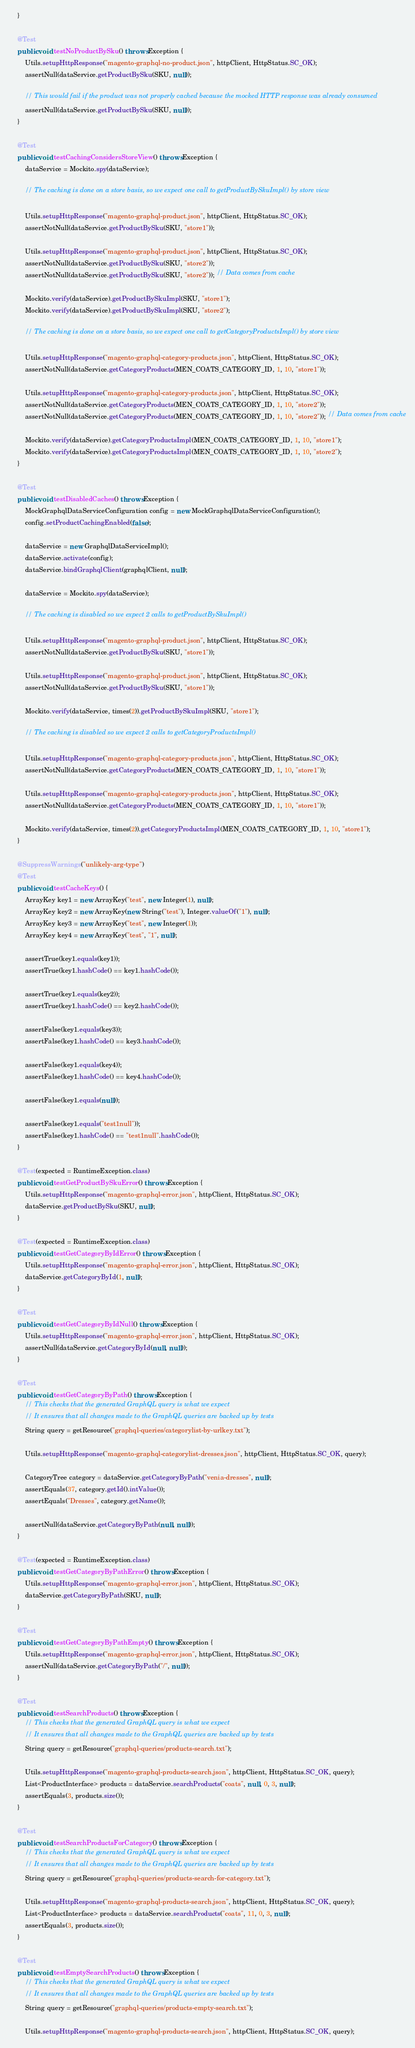<code> <loc_0><loc_0><loc_500><loc_500><_Java_>    }

    @Test
    public void testNoProductBySku() throws Exception {
        Utils.setupHttpResponse("magento-graphql-no-product.json", httpClient, HttpStatus.SC_OK);
        assertNull(dataService.getProductBySku(SKU, null));

        // This would fail if the product was not properly cached because the mocked HTTP response was already consumed
        assertNull(dataService.getProductBySku(SKU, null));
    }

    @Test
    public void testCachingConsidersStoreView() throws Exception {
        dataService = Mockito.spy(dataService);

        // The caching is done on a store basis, so we expect one call to getProductBySkuImpl() by store view

        Utils.setupHttpResponse("magento-graphql-product.json", httpClient, HttpStatus.SC_OK);
        assertNotNull(dataService.getProductBySku(SKU, "store1"));

        Utils.setupHttpResponse("magento-graphql-product.json", httpClient, HttpStatus.SC_OK);
        assertNotNull(dataService.getProductBySku(SKU, "store2"));
        assertNotNull(dataService.getProductBySku(SKU, "store2")); // Data comes from cache

        Mockito.verify(dataService).getProductBySkuImpl(SKU, "store1");
        Mockito.verify(dataService).getProductBySkuImpl(SKU, "store2");

        // The caching is done on a store basis, so we expect one call to getCategoryProductsImpl() by store view

        Utils.setupHttpResponse("magento-graphql-category-products.json", httpClient, HttpStatus.SC_OK);
        assertNotNull(dataService.getCategoryProducts(MEN_COATS_CATEGORY_ID, 1, 10, "store1"));

        Utils.setupHttpResponse("magento-graphql-category-products.json", httpClient, HttpStatus.SC_OK);
        assertNotNull(dataService.getCategoryProducts(MEN_COATS_CATEGORY_ID, 1, 10, "store2"));
        assertNotNull(dataService.getCategoryProducts(MEN_COATS_CATEGORY_ID, 1, 10, "store2")); // Data comes from cache

        Mockito.verify(dataService).getCategoryProductsImpl(MEN_COATS_CATEGORY_ID, 1, 10, "store1");
        Mockito.verify(dataService).getCategoryProductsImpl(MEN_COATS_CATEGORY_ID, 1, 10, "store2");
    }

    @Test
    public void testDisabledCaches() throws Exception {
        MockGraphqlDataServiceConfiguration config = new MockGraphqlDataServiceConfiguration();
        config.setProductCachingEnabled(false);

        dataService = new GraphqlDataServiceImpl();
        dataService.activate(config);
        dataService.bindGraphqlClient(graphqlClient, null);

        dataService = Mockito.spy(dataService);

        // The caching is disabled so we expect 2 calls to getProductBySkuImpl()

        Utils.setupHttpResponse("magento-graphql-product.json", httpClient, HttpStatus.SC_OK);
        assertNotNull(dataService.getProductBySku(SKU, "store1"));

        Utils.setupHttpResponse("magento-graphql-product.json", httpClient, HttpStatus.SC_OK);
        assertNotNull(dataService.getProductBySku(SKU, "store1"));

        Mockito.verify(dataService, times(2)).getProductBySkuImpl(SKU, "store1");

        // The caching is disabled so we expect 2 calls to getCategoryProductsImpl()

        Utils.setupHttpResponse("magento-graphql-category-products.json", httpClient, HttpStatus.SC_OK);
        assertNotNull(dataService.getCategoryProducts(MEN_COATS_CATEGORY_ID, 1, 10, "store1"));

        Utils.setupHttpResponse("magento-graphql-category-products.json", httpClient, HttpStatus.SC_OK);
        assertNotNull(dataService.getCategoryProducts(MEN_COATS_CATEGORY_ID, 1, 10, "store1"));

        Mockito.verify(dataService, times(2)).getCategoryProductsImpl(MEN_COATS_CATEGORY_ID, 1, 10, "store1");
    }

    @SuppressWarnings("unlikely-arg-type")
    @Test
    public void testCacheKeys() {
        ArrayKey key1 = new ArrayKey("test", new Integer(1), null);
        ArrayKey key2 = new ArrayKey(new String("test"), Integer.valueOf("1"), null);
        ArrayKey key3 = new ArrayKey("test", new Integer(1));
        ArrayKey key4 = new ArrayKey("test", "1", null);

        assertTrue(key1.equals(key1));
        assertTrue(key1.hashCode() == key1.hashCode());

        assertTrue(key1.equals(key2));
        assertTrue(key1.hashCode() == key2.hashCode());

        assertFalse(key1.equals(key3));
        assertFalse(key1.hashCode() == key3.hashCode());

        assertFalse(key1.equals(key4));
        assertFalse(key1.hashCode() == key4.hashCode());

        assertFalse(key1.equals(null));

        assertFalse(key1.equals("test1null"));
        assertFalse(key1.hashCode() == "test1null".hashCode());
    }

    @Test(expected = RuntimeException.class)
    public void testGetProductBySkuError() throws Exception {
        Utils.setupHttpResponse("magento-graphql-error.json", httpClient, HttpStatus.SC_OK);
        dataService.getProductBySku(SKU, null);
    }

    @Test(expected = RuntimeException.class)
    public void testGetCategoryByIdError() throws Exception {
        Utils.setupHttpResponse("magento-graphql-error.json", httpClient, HttpStatus.SC_OK);
        dataService.getCategoryById(1, null);
    }

    @Test
    public void testGetCategoryByIdNull() throws Exception {
        Utils.setupHttpResponse("magento-graphql-error.json", httpClient, HttpStatus.SC_OK);
        assertNull(dataService.getCategoryById(null, null));
    }

    @Test
    public void testGetCategoryByPath() throws Exception {
        // This checks that the generated GraphQL query is what we expect
        // It ensures that all changes made to the GraphQL queries are backed up by tests
        String query = getResource("graphql-queries/categorylist-by-urlkey.txt");

        Utils.setupHttpResponse("magento-graphql-categorylist-dresses.json", httpClient, HttpStatus.SC_OK, query);

        CategoryTree category = dataService.getCategoryByPath("venia-dresses", null);
        assertEquals(37, category.getId().intValue());
        assertEquals("Dresses", category.getName());

        assertNull(dataService.getCategoryByPath(null, null));
    }

    @Test(expected = RuntimeException.class)
    public void testGetCategoryByPathError() throws Exception {
        Utils.setupHttpResponse("magento-graphql-error.json", httpClient, HttpStatus.SC_OK);
        dataService.getCategoryByPath(SKU, null);
    }

    @Test
    public void testGetCategoryByPathEmpty() throws Exception {
        Utils.setupHttpResponse("magento-graphql-error.json", httpClient, HttpStatus.SC_OK);
        assertNull(dataService.getCategoryByPath("/", null));
    }

    @Test
    public void testSearchProducts() throws Exception {
        // This checks that the generated GraphQL query is what we expect
        // It ensures that all changes made to the GraphQL queries are backed up by tests
        String query = getResource("graphql-queries/products-search.txt");

        Utils.setupHttpResponse("magento-graphql-products-search.json", httpClient, HttpStatus.SC_OK, query);
        List<ProductInterface> products = dataService.searchProducts("coats", null, 0, 3, null);
        assertEquals(3, products.size());
    }

    @Test
    public void testSearchProductsForCategory() throws Exception {
        // This checks that the generated GraphQL query is what we expect
        // It ensures that all changes made to the GraphQL queries are backed up by tests
        String query = getResource("graphql-queries/products-search-for-category.txt");

        Utils.setupHttpResponse("magento-graphql-products-search.json", httpClient, HttpStatus.SC_OK, query);
        List<ProductInterface> products = dataService.searchProducts("coats", 11, 0, 3, null);
        assertEquals(3, products.size());
    }

    @Test
    public void testEmptySearchProducts() throws Exception {
        // This checks that the generated GraphQL query is what we expect
        // It ensures that all changes made to the GraphQL queries are backed up by tests
        String query = getResource("graphql-queries/products-empty-search.txt");

        Utils.setupHttpResponse("magento-graphql-products-search.json", httpClient, HttpStatus.SC_OK, query);</code> 